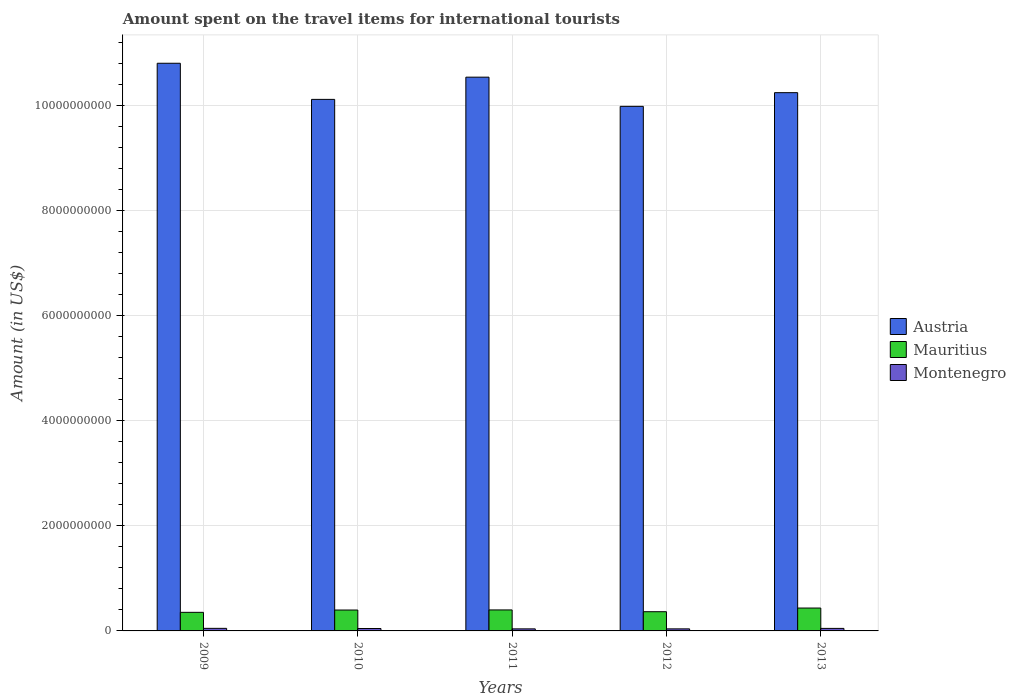How many different coloured bars are there?
Keep it short and to the point. 3. Are the number of bars per tick equal to the number of legend labels?
Make the answer very short. Yes. How many bars are there on the 5th tick from the left?
Keep it short and to the point. 3. How many bars are there on the 5th tick from the right?
Make the answer very short. 3. What is the label of the 3rd group of bars from the left?
Ensure brevity in your answer.  2011. What is the amount spent on the travel items for international tourists in Austria in 2009?
Provide a short and direct response. 1.08e+1. Across all years, what is the maximum amount spent on the travel items for international tourists in Mauritius?
Make the answer very short. 4.36e+08. Across all years, what is the minimum amount spent on the travel items for international tourists in Mauritius?
Offer a terse response. 3.54e+08. In which year was the amount spent on the travel items for international tourists in Mauritius maximum?
Offer a very short reply. 2013. In which year was the amount spent on the travel items for international tourists in Montenegro minimum?
Your answer should be very brief. 2011. What is the total amount spent on the travel items for international tourists in Mauritius in the graph?
Your answer should be very brief. 1.95e+09. What is the difference between the amount spent on the travel items for international tourists in Montenegro in 2010 and that in 2011?
Offer a very short reply. 7.00e+06. What is the difference between the amount spent on the travel items for international tourists in Austria in 2009 and the amount spent on the travel items for international tourists in Montenegro in 2013?
Your answer should be very brief. 1.08e+1. What is the average amount spent on the travel items for international tourists in Mauritius per year?
Make the answer very short. 3.91e+08. In the year 2009, what is the difference between the amount spent on the travel items for international tourists in Mauritius and amount spent on the travel items for international tourists in Austria?
Your answer should be compact. -1.05e+1. In how many years, is the amount spent on the travel items for international tourists in Mauritius greater than 10000000000 US$?
Keep it short and to the point. 0. What is the ratio of the amount spent on the travel items for international tourists in Montenegro in 2010 to that in 2012?
Your answer should be very brief. 1.18. What is the difference between the highest and the second highest amount spent on the travel items for international tourists in Mauritius?
Offer a very short reply. 3.60e+07. What does the 2nd bar from the left in 2012 represents?
Provide a succinct answer. Mauritius. What does the 3rd bar from the right in 2012 represents?
Ensure brevity in your answer.  Austria. Is it the case that in every year, the sum of the amount spent on the travel items for international tourists in Mauritius and amount spent on the travel items for international tourists in Austria is greater than the amount spent on the travel items for international tourists in Montenegro?
Offer a very short reply. Yes. How many bars are there?
Provide a succinct answer. 15. What is the difference between two consecutive major ticks on the Y-axis?
Offer a terse response. 2.00e+09. Are the values on the major ticks of Y-axis written in scientific E-notation?
Offer a very short reply. No. Does the graph contain grids?
Provide a succinct answer. Yes. Where does the legend appear in the graph?
Your response must be concise. Center right. What is the title of the graph?
Give a very brief answer. Amount spent on the travel items for international tourists. What is the label or title of the X-axis?
Make the answer very short. Years. What is the label or title of the Y-axis?
Keep it short and to the point. Amount (in US$). What is the Amount (in US$) of Austria in 2009?
Offer a terse response. 1.08e+1. What is the Amount (in US$) in Mauritius in 2009?
Your answer should be compact. 3.54e+08. What is the Amount (in US$) of Montenegro in 2009?
Keep it short and to the point. 4.90e+07. What is the Amount (in US$) of Austria in 2010?
Keep it short and to the point. 1.01e+1. What is the Amount (in US$) of Mauritius in 2010?
Keep it short and to the point. 3.98e+08. What is the Amount (in US$) in Montenegro in 2010?
Offer a terse response. 4.60e+07. What is the Amount (in US$) of Austria in 2011?
Offer a terse response. 1.05e+1. What is the Amount (in US$) of Mauritius in 2011?
Your answer should be very brief. 4.00e+08. What is the Amount (in US$) in Montenegro in 2011?
Your answer should be very brief. 3.90e+07. What is the Amount (in US$) of Austria in 2012?
Keep it short and to the point. 9.99e+09. What is the Amount (in US$) of Mauritius in 2012?
Make the answer very short. 3.66e+08. What is the Amount (in US$) of Montenegro in 2012?
Your answer should be very brief. 3.90e+07. What is the Amount (in US$) in Austria in 2013?
Your response must be concise. 1.03e+1. What is the Amount (in US$) of Mauritius in 2013?
Your answer should be very brief. 4.36e+08. What is the Amount (in US$) in Montenegro in 2013?
Your response must be concise. 4.80e+07. Across all years, what is the maximum Amount (in US$) in Austria?
Offer a terse response. 1.08e+1. Across all years, what is the maximum Amount (in US$) of Mauritius?
Your answer should be very brief. 4.36e+08. Across all years, what is the maximum Amount (in US$) of Montenegro?
Make the answer very short. 4.90e+07. Across all years, what is the minimum Amount (in US$) in Austria?
Provide a short and direct response. 9.99e+09. Across all years, what is the minimum Amount (in US$) of Mauritius?
Your answer should be very brief. 3.54e+08. Across all years, what is the minimum Amount (in US$) in Montenegro?
Provide a short and direct response. 3.90e+07. What is the total Amount (in US$) in Austria in the graph?
Your answer should be very brief. 5.17e+1. What is the total Amount (in US$) in Mauritius in the graph?
Your answer should be compact. 1.95e+09. What is the total Amount (in US$) in Montenegro in the graph?
Your answer should be very brief. 2.21e+08. What is the difference between the Amount (in US$) in Austria in 2009 and that in 2010?
Keep it short and to the point. 6.88e+08. What is the difference between the Amount (in US$) in Mauritius in 2009 and that in 2010?
Provide a short and direct response. -4.40e+07. What is the difference between the Amount (in US$) of Austria in 2009 and that in 2011?
Provide a succinct answer. 2.65e+08. What is the difference between the Amount (in US$) of Mauritius in 2009 and that in 2011?
Ensure brevity in your answer.  -4.60e+07. What is the difference between the Amount (in US$) of Montenegro in 2009 and that in 2011?
Provide a short and direct response. 1.00e+07. What is the difference between the Amount (in US$) of Austria in 2009 and that in 2012?
Your answer should be very brief. 8.21e+08. What is the difference between the Amount (in US$) in Mauritius in 2009 and that in 2012?
Ensure brevity in your answer.  -1.20e+07. What is the difference between the Amount (in US$) in Montenegro in 2009 and that in 2012?
Provide a succinct answer. 1.00e+07. What is the difference between the Amount (in US$) in Austria in 2009 and that in 2013?
Your response must be concise. 5.60e+08. What is the difference between the Amount (in US$) in Mauritius in 2009 and that in 2013?
Provide a short and direct response. -8.20e+07. What is the difference between the Amount (in US$) of Montenegro in 2009 and that in 2013?
Ensure brevity in your answer.  1.00e+06. What is the difference between the Amount (in US$) of Austria in 2010 and that in 2011?
Your answer should be very brief. -4.23e+08. What is the difference between the Amount (in US$) in Austria in 2010 and that in 2012?
Your response must be concise. 1.33e+08. What is the difference between the Amount (in US$) in Mauritius in 2010 and that in 2012?
Offer a terse response. 3.20e+07. What is the difference between the Amount (in US$) of Austria in 2010 and that in 2013?
Give a very brief answer. -1.28e+08. What is the difference between the Amount (in US$) of Mauritius in 2010 and that in 2013?
Your answer should be compact. -3.80e+07. What is the difference between the Amount (in US$) in Montenegro in 2010 and that in 2013?
Keep it short and to the point. -2.00e+06. What is the difference between the Amount (in US$) of Austria in 2011 and that in 2012?
Offer a terse response. 5.56e+08. What is the difference between the Amount (in US$) of Mauritius in 2011 and that in 2012?
Ensure brevity in your answer.  3.40e+07. What is the difference between the Amount (in US$) of Austria in 2011 and that in 2013?
Your answer should be compact. 2.95e+08. What is the difference between the Amount (in US$) in Mauritius in 2011 and that in 2013?
Offer a very short reply. -3.60e+07. What is the difference between the Amount (in US$) of Montenegro in 2011 and that in 2013?
Offer a very short reply. -9.00e+06. What is the difference between the Amount (in US$) of Austria in 2012 and that in 2013?
Provide a succinct answer. -2.61e+08. What is the difference between the Amount (in US$) in Mauritius in 2012 and that in 2013?
Keep it short and to the point. -7.00e+07. What is the difference between the Amount (in US$) in Montenegro in 2012 and that in 2013?
Offer a terse response. -9.00e+06. What is the difference between the Amount (in US$) of Austria in 2009 and the Amount (in US$) of Mauritius in 2010?
Offer a very short reply. 1.04e+1. What is the difference between the Amount (in US$) of Austria in 2009 and the Amount (in US$) of Montenegro in 2010?
Provide a succinct answer. 1.08e+1. What is the difference between the Amount (in US$) in Mauritius in 2009 and the Amount (in US$) in Montenegro in 2010?
Offer a terse response. 3.08e+08. What is the difference between the Amount (in US$) of Austria in 2009 and the Amount (in US$) of Mauritius in 2011?
Offer a terse response. 1.04e+1. What is the difference between the Amount (in US$) of Austria in 2009 and the Amount (in US$) of Montenegro in 2011?
Make the answer very short. 1.08e+1. What is the difference between the Amount (in US$) in Mauritius in 2009 and the Amount (in US$) in Montenegro in 2011?
Your answer should be very brief. 3.15e+08. What is the difference between the Amount (in US$) in Austria in 2009 and the Amount (in US$) in Mauritius in 2012?
Make the answer very short. 1.04e+1. What is the difference between the Amount (in US$) of Austria in 2009 and the Amount (in US$) of Montenegro in 2012?
Offer a terse response. 1.08e+1. What is the difference between the Amount (in US$) of Mauritius in 2009 and the Amount (in US$) of Montenegro in 2012?
Keep it short and to the point. 3.15e+08. What is the difference between the Amount (in US$) in Austria in 2009 and the Amount (in US$) in Mauritius in 2013?
Offer a terse response. 1.04e+1. What is the difference between the Amount (in US$) in Austria in 2009 and the Amount (in US$) in Montenegro in 2013?
Ensure brevity in your answer.  1.08e+1. What is the difference between the Amount (in US$) in Mauritius in 2009 and the Amount (in US$) in Montenegro in 2013?
Offer a terse response. 3.06e+08. What is the difference between the Amount (in US$) of Austria in 2010 and the Amount (in US$) of Mauritius in 2011?
Make the answer very short. 9.72e+09. What is the difference between the Amount (in US$) in Austria in 2010 and the Amount (in US$) in Montenegro in 2011?
Keep it short and to the point. 1.01e+1. What is the difference between the Amount (in US$) in Mauritius in 2010 and the Amount (in US$) in Montenegro in 2011?
Your response must be concise. 3.59e+08. What is the difference between the Amount (in US$) in Austria in 2010 and the Amount (in US$) in Mauritius in 2012?
Provide a succinct answer. 9.76e+09. What is the difference between the Amount (in US$) of Austria in 2010 and the Amount (in US$) of Montenegro in 2012?
Give a very brief answer. 1.01e+1. What is the difference between the Amount (in US$) of Mauritius in 2010 and the Amount (in US$) of Montenegro in 2012?
Make the answer very short. 3.59e+08. What is the difference between the Amount (in US$) in Austria in 2010 and the Amount (in US$) in Mauritius in 2013?
Ensure brevity in your answer.  9.69e+09. What is the difference between the Amount (in US$) of Austria in 2010 and the Amount (in US$) of Montenegro in 2013?
Provide a succinct answer. 1.01e+1. What is the difference between the Amount (in US$) of Mauritius in 2010 and the Amount (in US$) of Montenegro in 2013?
Offer a terse response. 3.50e+08. What is the difference between the Amount (in US$) of Austria in 2011 and the Amount (in US$) of Mauritius in 2012?
Ensure brevity in your answer.  1.02e+1. What is the difference between the Amount (in US$) of Austria in 2011 and the Amount (in US$) of Montenegro in 2012?
Give a very brief answer. 1.05e+1. What is the difference between the Amount (in US$) of Mauritius in 2011 and the Amount (in US$) of Montenegro in 2012?
Provide a short and direct response. 3.61e+08. What is the difference between the Amount (in US$) of Austria in 2011 and the Amount (in US$) of Mauritius in 2013?
Offer a very short reply. 1.01e+1. What is the difference between the Amount (in US$) of Austria in 2011 and the Amount (in US$) of Montenegro in 2013?
Ensure brevity in your answer.  1.05e+1. What is the difference between the Amount (in US$) in Mauritius in 2011 and the Amount (in US$) in Montenegro in 2013?
Your answer should be very brief. 3.52e+08. What is the difference between the Amount (in US$) in Austria in 2012 and the Amount (in US$) in Mauritius in 2013?
Provide a short and direct response. 9.56e+09. What is the difference between the Amount (in US$) in Austria in 2012 and the Amount (in US$) in Montenegro in 2013?
Keep it short and to the point. 9.94e+09. What is the difference between the Amount (in US$) in Mauritius in 2012 and the Amount (in US$) in Montenegro in 2013?
Offer a terse response. 3.18e+08. What is the average Amount (in US$) of Austria per year?
Offer a terse response. 1.03e+1. What is the average Amount (in US$) of Mauritius per year?
Your answer should be very brief. 3.91e+08. What is the average Amount (in US$) of Montenegro per year?
Your answer should be very brief. 4.42e+07. In the year 2009, what is the difference between the Amount (in US$) of Austria and Amount (in US$) of Mauritius?
Offer a very short reply. 1.05e+1. In the year 2009, what is the difference between the Amount (in US$) of Austria and Amount (in US$) of Montenegro?
Your answer should be compact. 1.08e+1. In the year 2009, what is the difference between the Amount (in US$) in Mauritius and Amount (in US$) in Montenegro?
Make the answer very short. 3.05e+08. In the year 2010, what is the difference between the Amount (in US$) of Austria and Amount (in US$) of Mauritius?
Provide a succinct answer. 9.73e+09. In the year 2010, what is the difference between the Amount (in US$) in Austria and Amount (in US$) in Montenegro?
Give a very brief answer. 1.01e+1. In the year 2010, what is the difference between the Amount (in US$) of Mauritius and Amount (in US$) of Montenegro?
Provide a succinct answer. 3.52e+08. In the year 2011, what is the difference between the Amount (in US$) of Austria and Amount (in US$) of Mauritius?
Your answer should be compact. 1.01e+1. In the year 2011, what is the difference between the Amount (in US$) of Austria and Amount (in US$) of Montenegro?
Keep it short and to the point. 1.05e+1. In the year 2011, what is the difference between the Amount (in US$) in Mauritius and Amount (in US$) in Montenegro?
Make the answer very short. 3.61e+08. In the year 2012, what is the difference between the Amount (in US$) of Austria and Amount (in US$) of Mauritius?
Give a very brief answer. 9.63e+09. In the year 2012, what is the difference between the Amount (in US$) in Austria and Amount (in US$) in Montenegro?
Make the answer very short. 9.95e+09. In the year 2012, what is the difference between the Amount (in US$) in Mauritius and Amount (in US$) in Montenegro?
Make the answer very short. 3.27e+08. In the year 2013, what is the difference between the Amount (in US$) in Austria and Amount (in US$) in Mauritius?
Offer a very short reply. 9.82e+09. In the year 2013, what is the difference between the Amount (in US$) of Austria and Amount (in US$) of Montenegro?
Make the answer very short. 1.02e+1. In the year 2013, what is the difference between the Amount (in US$) of Mauritius and Amount (in US$) of Montenegro?
Keep it short and to the point. 3.88e+08. What is the ratio of the Amount (in US$) in Austria in 2009 to that in 2010?
Keep it short and to the point. 1.07. What is the ratio of the Amount (in US$) of Mauritius in 2009 to that in 2010?
Give a very brief answer. 0.89. What is the ratio of the Amount (in US$) of Montenegro in 2009 to that in 2010?
Keep it short and to the point. 1.07. What is the ratio of the Amount (in US$) in Austria in 2009 to that in 2011?
Keep it short and to the point. 1.03. What is the ratio of the Amount (in US$) of Mauritius in 2009 to that in 2011?
Your answer should be very brief. 0.89. What is the ratio of the Amount (in US$) of Montenegro in 2009 to that in 2011?
Ensure brevity in your answer.  1.26. What is the ratio of the Amount (in US$) in Austria in 2009 to that in 2012?
Provide a succinct answer. 1.08. What is the ratio of the Amount (in US$) in Mauritius in 2009 to that in 2012?
Your response must be concise. 0.97. What is the ratio of the Amount (in US$) in Montenegro in 2009 to that in 2012?
Provide a short and direct response. 1.26. What is the ratio of the Amount (in US$) of Austria in 2009 to that in 2013?
Offer a terse response. 1.05. What is the ratio of the Amount (in US$) of Mauritius in 2009 to that in 2013?
Offer a terse response. 0.81. What is the ratio of the Amount (in US$) in Montenegro in 2009 to that in 2013?
Make the answer very short. 1.02. What is the ratio of the Amount (in US$) in Austria in 2010 to that in 2011?
Make the answer very short. 0.96. What is the ratio of the Amount (in US$) of Montenegro in 2010 to that in 2011?
Give a very brief answer. 1.18. What is the ratio of the Amount (in US$) of Austria in 2010 to that in 2012?
Offer a terse response. 1.01. What is the ratio of the Amount (in US$) in Mauritius in 2010 to that in 2012?
Provide a short and direct response. 1.09. What is the ratio of the Amount (in US$) in Montenegro in 2010 to that in 2012?
Offer a very short reply. 1.18. What is the ratio of the Amount (in US$) of Austria in 2010 to that in 2013?
Offer a very short reply. 0.99. What is the ratio of the Amount (in US$) of Mauritius in 2010 to that in 2013?
Your answer should be compact. 0.91. What is the ratio of the Amount (in US$) of Austria in 2011 to that in 2012?
Make the answer very short. 1.06. What is the ratio of the Amount (in US$) in Mauritius in 2011 to that in 2012?
Offer a very short reply. 1.09. What is the ratio of the Amount (in US$) in Austria in 2011 to that in 2013?
Provide a succinct answer. 1.03. What is the ratio of the Amount (in US$) in Mauritius in 2011 to that in 2013?
Offer a terse response. 0.92. What is the ratio of the Amount (in US$) of Montenegro in 2011 to that in 2013?
Offer a very short reply. 0.81. What is the ratio of the Amount (in US$) of Austria in 2012 to that in 2013?
Provide a short and direct response. 0.97. What is the ratio of the Amount (in US$) in Mauritius in 2012 to that in 2013?
Your response must be concise. 0.84. What is the ratio of the Amount (in US$) in Montenegro in 2012 to that in 2013?
Give a very brief answer. 0.81. What is the difference between the highest and the second highest Amount (in US$) of Austria?
Make the answer very short. 2.65e+08. What is the difference between the highest and the second highest Amount (in US$) of Mauritius?
Make the answer very short. 3.60e+07. What is the difference between the highest and the second highest Amount (in US$) in Montenegro?
Offer a terse response. 1.00e+06. What is the difference between the highest and the lowest Amount (in US$) of Austria?
Offer a terse response. 8.21e+08. What is the difference between the highest and the lowest Amount (in US$) in Mauritius?
Ensure brevity in your answer.  8.20e+07. What is the difference between the highest and the lowest Amount (in US$) of Montenegro?
Provide a succinct answer. 1.00e+07. 